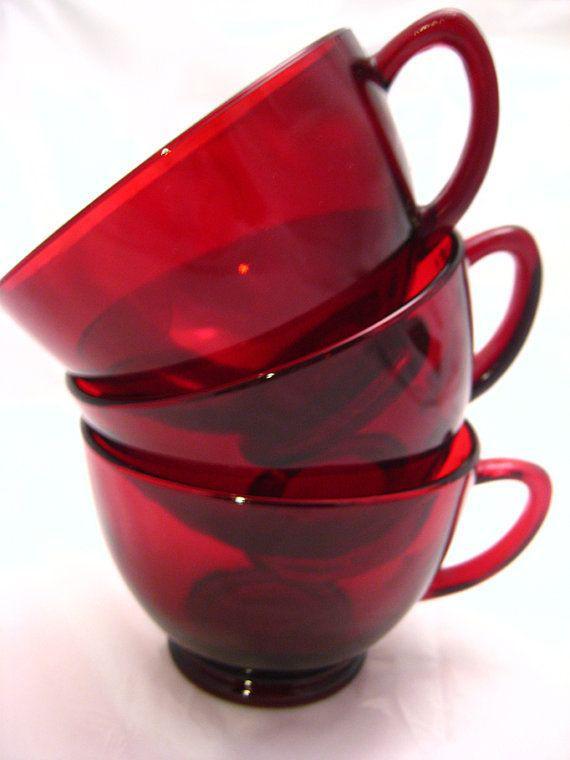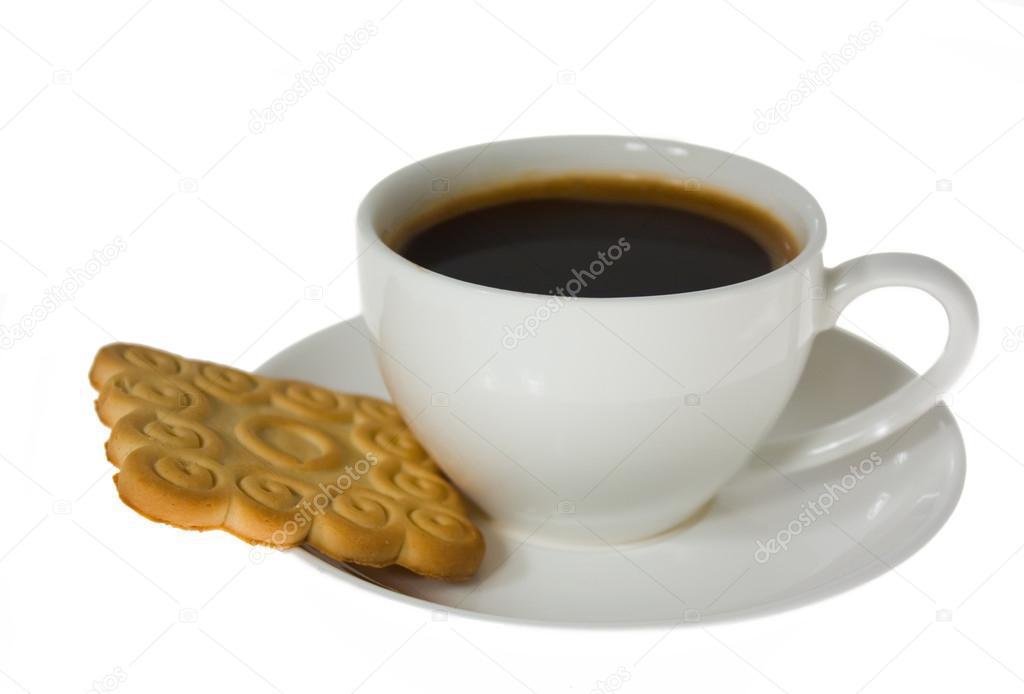The first image is the image on the left, the second image is the image on the right. Assess this claim about the two images: "In one image, a liquid is being poured into a white cup from a white tea kettle". Correct or not? Answer yes or no. No. The first image is the image on the left, the second image is the image on the right. For the images shown, is this caption "A white teapot is pouring tea into a cup in one of the images." true? Answer yes or no. No. 